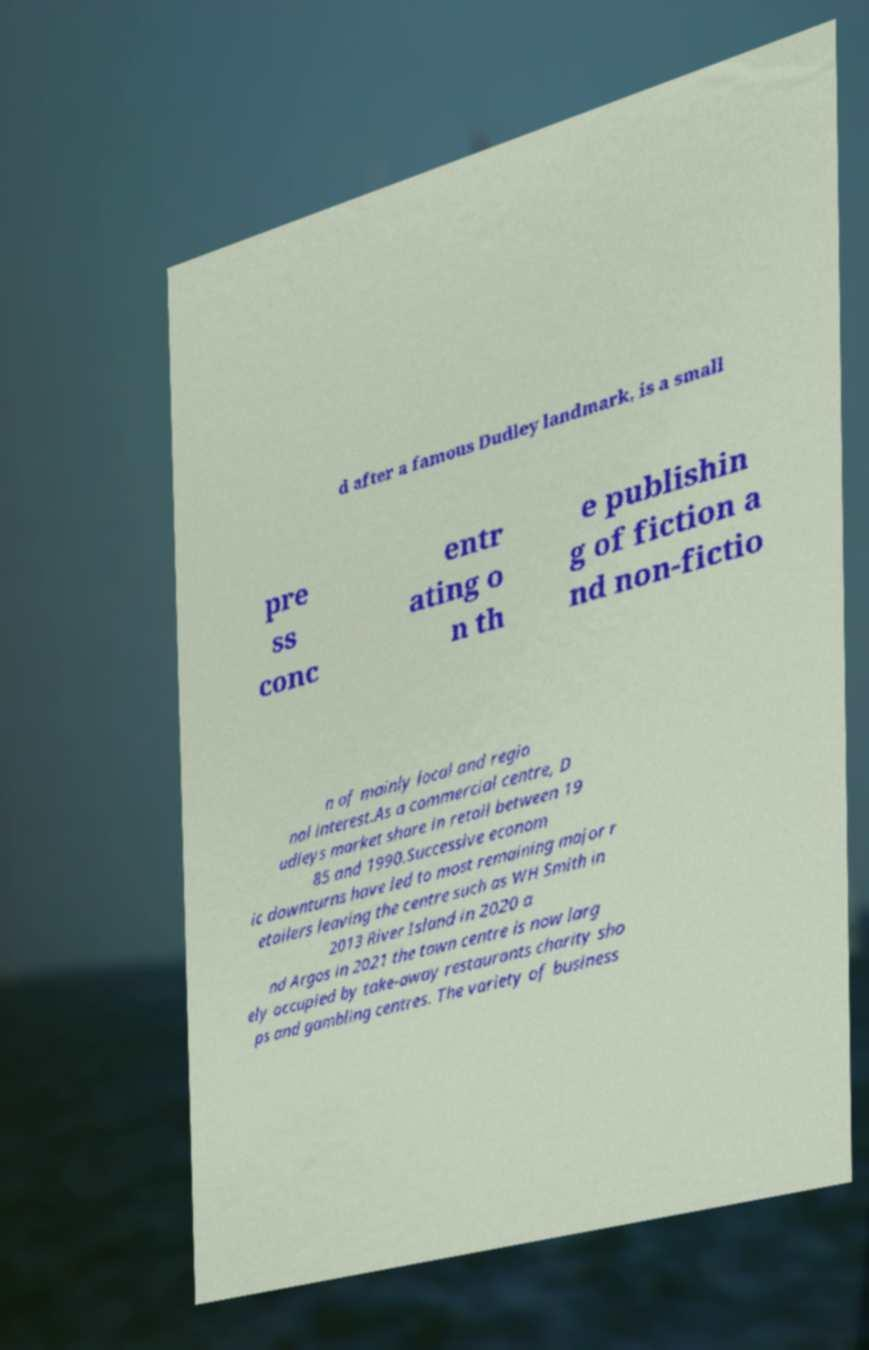Could you assist in decoding the text presented in this image and type it out clearly? d after a famous Dudley landmark, is a small pre ss conc entr ating o n th e publishin g of fiction a nd non-fictio n of mainly local and regio nal interest.As a commercial centre, D udleys market share in retail between 19 85 and 1990.Successive econom ic downturns have led to most remaining major r etailers leaving the centre such as WH Smith in 2013 River Island in 2020 a nd Argos in 2021 the town centre is now larg ely occupied by take-away restaurants charity sho ps and gambling centres. The variety of business 